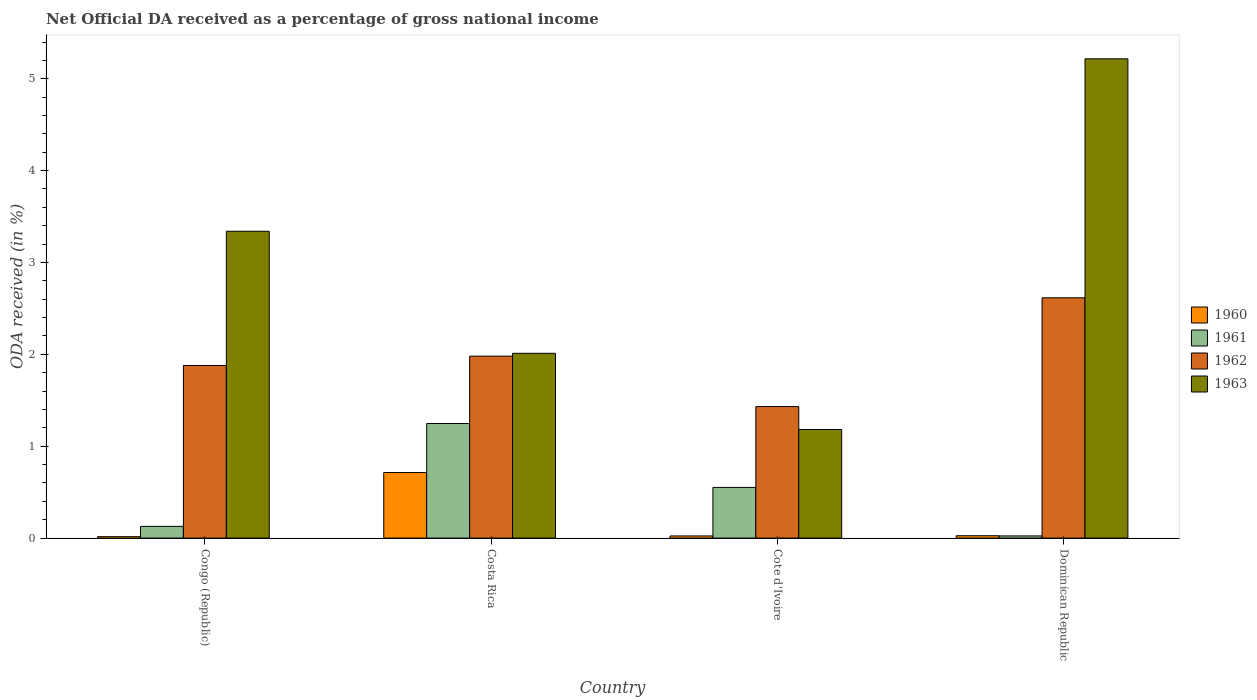Are the number of bars per tick equal to the number of legend labels?
Offer a very short reply. Yes. What is the label of the 3rd group of bars from the left?
Offer a very short reply. Cote d'Ivoire. In how many cases, is the number of bars for a given country not equal to the number of legend labels?
Your answer should be compact. 0. What is the net official DA received in 1960 in Cote d'Ivoire?
Make the answer very short. 0.02. Across all countries, what is the maximum net official DA received in 1960?
Ensure brevity in your answer.  0.71. Across all countries, what is the minimum net official DA received in 1962?
Provide a short and direct response. 1.43. In which country was the net official DA received in 1961 maximum?
Your answer should be very brief. Costa Rica. In which country was the net official DA received in 1960 minimum?
Ensure brevity in your answer.  Congo (Republic). What is the total net official DA received in 1962 in the graph?
Your response must be concise. 7.91. What is the difference between the net official DA received in 1960 in Congo (Republic) and that in Dominican Republic?
Your answer should be compact. -0.01. What is the difference between the net official DA received in 1961 in Dominican Republic and the net official DA received in 1963 in Congo (Republic)?
Provide a succinct answer. -3.32. What is the average net official DA received in 1963 per country?
Make the answer very short. 2.94. What is the difference between the net official DA received of/in 1963 and net official DA received of/in 1962 in Dominican Republic?
Provide a short and direct response. 2.6. What is the ratio of the net official DA received in 1961 in Congo (Republic) to that in Cote d'Ivoire?
Provide a short and direct response. 0.23. Is the net official DA received in 1960 in Costa Rica less than that in Cote d'Ivoire?
Offer a terse response. No. What is the difference between the highest and the second highest net official DA received in 1962?
Your response must be concise. -0.64. What is the difference between the highest and the lowest net official DA received in 1962?
Make the answer very short. 1.18. In how many countries, is the net official DA received in 1960 greater than the average net official DA received in 1960 taken over all countries?
Your answer should be very brief. 1. How many bars are there?
Provide a short and direct response. 16. Are all the bars in the graph horizontal?
Your response must be concise. No. Are the values on the major ticks of Y-axis written in scientific E-notation?
Keep it short and to the point. No. Does the graph contain any zero values?
Offer a terse response. No. Where does the legend appear in the graph?
Offer a very short reply. Center right. What is the title of the graph?
Give a very brief answer. Net Official DA received as a percentage of gross national income. Does "1962" appear as one of the legend labels in the graph?
Provide a short and direct response. Yes. What is the label or title of the X-axis?
Offer a very short reply. Country. What is the label or title of the Y-axis?
Your response must be concise. ODA received (in %). What is the ODA received (in %) in 1960 in Congo (Republic)?
Your answer should be compact. 0.02. What is the ODA received (in %) in 1961 in Congo (Republic)?
Ensure brevity in your answer.  0.13. What is the ODA received (in %) of 1962 in Congo (Republic)?
Keep it short and to the point. 1.88. What is the ODA received (in %) in 1963 in Congo (Republic)?
Offer a very short reply. 3.34. What is the ODA received (in %) of 1960 in Costa Rica?
Keep it short and to the point. 0.71. What is the ODA received (in %) of 1961 in Costa Rica?
Provide a succinct answer. 1.25. What is the ODA received (in %) of 1962 in Costa Rica?
Keep it short and to the point. 1.98. What is the ODA received (in %) of 1963 in Costa Rica?
Make the answer very short. 2.01. What is the ODA received (in %) in 1960 in Cote d'Ivoire?
Provide a short and direct response. 0.02. What is the ODA received (in %) of 1961 in Cote d'Ivoire?
Your answer should be compact. 0.55. What is the ODA received (in %) in 1962 in Cote d'Ivoire?
Ensure brevity in your answer.  1.43. What is the ODA received (in %) in 1963 in Cote d'Ivoire?
Your response must be concise. 1.18. What is the ODA received (in %) of 1960 in Dominican Republic?
Offer a very short reply. 0.03. What is the ODA received (in %) in 1961 in Dominican Republic?
Your answer should be very brief. 0.02. What is the ODA received (in %) in 1962 in Dominican Republic?
Offer a terse response. 2.62. What is the ODA received (in %) of 1963 in Dominican Republic?
Ensure brevity in your answer.  5.22. Across all countries, what is the maximum ODA received (in %) of 1960?
Your answer should be very brief. 0.71. Across all countries, what is the maximum ODA received (in %) of 1961?
Ensure brevity in your answer.  1.25. Across all countries, what is the maximum ODA received (in %) of 1962?
Your response must be concise. 2.62. Across all countries, what is the maximum ODA received (in %) in 1963?
Your answer should be compact. 5.22. Across all countries, what is the minimum ODA received (in %) of 1960?
Your answer should be compact. 0.02. Across all countries, what is the minimum ODA received (in %) in 1961?
Make the answer very short. 0.02. Across all countries, what is the minimum ODA received (in %) in 1962?
Ensure brevity in your answer.  1.43. Across all countries, what is the minimum ODA received (in %) of 1963?
Make the answer very short. 1.18. What is the total ODA received (in %) of 1960 in the graph?
Your answer should be compact. 0.78. What is the total ODA received (in %) in 1961 in the graph?
Give a very brief answer. 1.95. What is the total ODA received (in %) of 1962 in the graph?
Offer a terse response. 7.91. What is the total ODA received (in %) of 1963 in the graph?
Offer a very short reply. 11.75. What is the difference between the ODA received (in %) in 1960 in Congo (Republic) and that in Costa Rica?
Your answer should be compact. -0.7. What is the difference between the ODA received (in %) in 1961 in Congo (Republic) and that in Costa Rica?
Your answer should be compact. -1.12. What is the difference between the ODA received (in %) in 1962 in Congo (Republic) and that in Costa Rica?
Give a very brief answer. -0.1. What is the difference between the ODA received (in %) of 1963 in Congo (Republic) and that in Costa Rica?
Make the answer very short. 1.33. What is the difference between the ODA received (in %) of 1960 in Congo (Republic) and that in Cote d'Ivoire?
Provide a succinct answer. -0.01. What is the difference between the ODA received (in %) in 1961 in Congo (Republic) and that in Cote d'Ivoire?
Provide a short and direct response. -0.42. What is the difference between the ODA received (in %) in 1962 in Congo (Republic) and that in Cote d'Ivoire?
Provide a succinct answer. 0.45. What is the difference between the ODA received (in %) of 1963 in Congo (Republic) and that in Cote d'Ivoire?
Offer a terse response. 2.16. What is the difference between the ODA received (in %) of 1960 in Congo (Republic) and that in Dominican Republic?
Give a very brief answer. -0.01. What is the difference between the ODA received (in %) of 1961 in Congo (Republic) and that in Dominican Republic?
Your response must be concise. 0.1. What is the difference between the ODA received (in %) in 1962 in Congo (Republic) and that in Dominican Republic?
Offer a terse response. -0.74. What is the difference between the ODA received (in %) of 1963 in Congo (Republic) and that in Dominican Republic?
Provide a short and direct response. -1.88. What is the difference between the ODA received (in %) of 1960 in Costa Rica and that in Cote d'Ivoire?
Keep it short and to the point. 0.69. What is the difference between the ODA received (in %) in 1961 in Costa Rica and that in Cote d'Ivoire?
Keep it short and to the point. 0.7. What is the difference between the ODA received (in %) in 1962 in Costa Rica and that in Cote d'Ivoire?
Keep it short and to the point. 0.55. What is the difference between the ODA received (in %) in 1963 in Costa Rica and that in Cote d'Ivoire?
Make the answer very short. 0.83. What is the difference between the ODA received (in %) of 1960 in Costa Rica and that in Dominican Republic?
Offer a terse response. 0.69. What is the difference between the ODA received (in %) of 1961 in Costa Rica and that in Dominican Republic?
Your answer should be very brief. 1.22. What is the difference between the ODA received (in %) in 1962 in Costa Rica and that in Dominican Republic?
Your answer should be very brief. -0.64. What is the difference between the ODA received (in %) in 1963 in Costa Rica and that in Dominican Republic?
Make the answer very short. -3.21. What is the difference between the ODA received (in %) of 1960 in Cote d'Ivoire and that in Dominican Republic?
Ensure brevity in your answer.  -0. What is the difference between the ODA received (in %) in 1961 in Cote d'Ivoire and that in Dominican Republic?
Make the answer very short. 0.53. What is the difference between the ODA received (in %) in 1962 in Cote d'Ivoire and that in Dominican Republic?
Offer a very short reply. -1.18. What is the difference between the ODA received (in %) of 1963 in Cote d'Ivoire and that in Dominican Republic?
Make the answer very short. -4.03. What is the difference between the ODA received (in %) of 1960 in Congo (Republic) and the ODA received (in %) of 1961 in Costa Rica?
Make the answer very short. -1.23. What is the difference between the ODA received (in %) in 1960 in Congo (Republic) and the ODA received (in %) in 1962 in Costa Rica?
Your answer should be compact. -1.96. What is the difference between the ODA received (in %) of 1960 in Congo (Republic) and the ODA received (in %) of 1963 in Costa Rica?
Offer a very short reply. -2. What is the difference between the ODA received (in %) in 1961 in Congo (Republic) and the ODA received (in %) in 1962 in Costa Rica?
Keep it short and to the point. -1.85. What is the difference between the ODA received (in %) of 1961 in Congo (Republic) and the ODA received (in %) of 1963 in Costa Rica?
Your answer should be very brief. -1.88. What is the difference between the ODA received (in %) in 1962 in Congo (Republic) and the ODA received (in %) in 1963 in Costa Rica?
Keep it short and to the point. -0.13. What is the difference between the ODA received (in %) of 1960 in Congo (Republic) and the ODA received (in %) of 1961 in Cote d'Ivoire?
Your answer should be compact. -0.54. What is the difference between the ODA received (in %) in 1960 in Congo (Republic) and the ODA received (in %) in 1962 in Cote d'Ivoire?
Provide a succinct answer. -1.42. What is the difference between the ODA received (in %) in 1960 in Congo (Republic) and the ODA received (in %) in 1963 in Cote d'Ivoire?
Make the answer very short. -1.17. What is the difference between the ODA received (in %) in 1961 in Congo (Republic) and the ODA received (in %) in 1962 in Cote d'Ivoire?
Give a very brief answer. -1.3. What is the difference between the ODA received (in %) of 1961 in Congo (Republic) and the ODA received (in %) of 1963 in Cote d'Ivoire?
Give a very brief answer. -1.05. What is the difference between the ODA received (in %) in 1962 in Congo (Republic) and the ODA received (in %) in 1963 in Cote d'Ivoire?
Your answer should be very brief. 0.7. What is the difference between the ODA received (in %) in 1960 in Congo (Republic) and the ODA received (in %) in 1961 in Dominican Republic?
Your response must be concise. -0.01. What is the difference between the ODA received (in %) of 1960 in Congo (Republic) and the ODA received (in %) of 1962 in Dominican Republic?
Your answer should be very brief. -2.6. What is the difference between the ODA received (in %) in 1960 in Congo (Republic) and the ODA received (in %) in 1963 in Dominican Republic?
Keep it short and to the point. -5.2. What is the difference between the ODA received (in %) in 1961 in Congo (Republic) and the ODA received (in %) in 1962 in Dominican Republic?
Offer a very short reply. -2.49. What is the difference between the ODA received (in %) in 1961 in Congo (Republic) and the ODA received (in %) in 1963 in Dominican Republic?
Your response must be concise. -5.09. What is the difference between the ODA received (in %) of 1962 in Congo (Republic) and the ODA received (in %) of 1963 in Dominican Republic?
Keep it short and to the point. -3.34. What is the difference between the ODA received (in %) of 1960 in Costa Rica and the ODA received (in %) of 1961 in Cote d'Ivoire?
Your response must be concise. 0.16. What is the difference between the ODA received (in %) of 1960 in Costa Rica and the ODA received (in %) of 1962 in Cote d'Ivoire?
Keep it short and to the point. -0.72. What is the difference between the ODA received (in %) of 1960 in Costa Rica and the ODA received (in %) of 1963 in Cote d'Ivoire?
Offer a very short reply. -0.47. What is the difference between the ODA received (in %) of 1961 in Costa Rica and the ODA received (in %) of 1962 in Cote d'Ivoire?
Offer a very short reply. -0.18. What is the difference between the ODA received (in %) in 1961 in Costa Rica and the ODA received (in %) in 1963 in Cote d'Ivoire?
Give a very brief answer. 0.07. What is the difference between the ODA received (in %) in 1962 in Costa Rica and the ODA received (in %) in 1963 in Cote d'Ivoire?
Offer a very short reply. 0.8. What is the difference between the ODA received (in %) in 1960 in Costa Rica and the ODA received (in %) in 1961 in Dominican Republic?
Your answer should be compact. 0.69. What is the difference between the ODA received (in %) in 1960 in Costa Rica and the ODA received (in %) in 1962 in Dominican Republic?
Keep it short and to the point. -1.9. What is the difference between the ODA received (in %) of 1960 in Costa Rica and the ODA received (in %) of 1963 in Dominican Republic?
Keep it short and to the point. -4.5. What is the difference between the ODA received (in %) of 1961 in Costa Rica and the ODA received (in %) of 1962 in Dominican Republic?
Your response must be concise. -1.37. What is the difference between the ODA received (in %) of 1961 in Costa Rica and the ODA received (in %) of 1963 in Dominican Republic?
Ensure brevity in your answer.  -3.97. What is the difference between the ODA received (in %) of 1962 in Costa Rica and the ODA received (in %) of 1963 in Dominican Republic?
Make the answer very short. -3.24. What is the difference between the ODA received (in %) of 1960 in Cote d'Ivoire and the ODA received (in %) of 1961 in Dominican Republic?
Provide a short and direct response. -0. What is the difference between the ODA received (in %) in 1960 in Cote d'Ivoire and the ODA received (in %) in 1962 in Dominican Republic?
Give a very brief answer. -2.59. What is the difference between the ODA received (in %) of 1960 in Cote d'Ivoire and the ODA received (in %) of 1963 in Dominican Republic?
Offer a terse response. -5.19. What is the difference between the ODA received (in %) of 1961 in Cote d'Ivoire and the ODA received (in %) of 1962 in Dominican Republic?
Offer a terse response. -2.06. What is the difference between the ODA received (in %) of 1961 in Cote d'Ivoire and the ODA received (in %) of 1963 in Dominican Republic?
Provide a short and direct response. -4.67. What is the difference between the ODA received (in %) of 1962 in Cote d'Ivoire and the ODA received (in %) of 1963 in Dominican Republic?
Your response must be concise. -3.79. What is the average ODA received (in %) in 1960 per country?
Provide a short and direct response. 0.19. What is the average ODA received (in %) of 1961 per country?
Make the answer very short. 0.49. What is the average ODA received (in %) of 1962 per country?
Provide a succinct answer. 1.98. What is the average ODA received (in %) of 1963 per country?
Ensure brevity in your answer.  2.94. What is the difference between the ODA received (in %) of 1960 and ODA received (in %) of 1961 in Congo (Republic)?
Give a very brief answer. -0.11. What is the difference between the ODA received (in %) of 1960 and ODA received (in %) of 1962 in Congo (Republic)?
Keep it short and to the point. -1.86. What is the difference between the ODA received (in %) in 1960 and ODA received (in %) in 1963 in Congo (Republic)?
Give a very brief answer. -3.32. What is the difference between the ODA received (in %) of 1961 and ODA received (in %) of 1962 in Congo (Republic)?
Your response must be concise. -1.75. What is the difference between the ODA received (in %) in 1961 and ODA received (in %) in 1963 in Congo (Republic)?
Make the answer very short. -3.21. What is the difference between the ODA received (in %) in 1962 and ODA received (in %) in 1963 in Congo (Republic)?
Offer a very short reply. -1.46. What is the difference between the ODA received (in %) of 1960 and ODA received (in %) of 1961 in Costa Rica?
Your answer should be very brief. -0.53. What is the difference between the ODA received (in %) in 1960 and ODA received (in %) in 1962 in Costa Rica?
Keep it short and to the point. -1.27. What is the difference between the ODA received (in %) in 1960 and ODA received (in %) in 1963 in Costa Rica?
Make the answer very short. -1.3. What is the difference between the ODA received (in %) of 1961 and ODA received (in %) of 1962 in Costa Rica?
Provide a short and direct response. -0.73. What is the difference between the ODA received (in %) in 1961 and ODA received (in %) in 1963 in Costa Rica?
Keep it short and to the point. -0.76. What is the difference between the ODA received (in %) of 1962 and ODA received (in %) of 1963 in Costa Rica?
Make the answer very short. -0.03. What is the difference between the ODA received (in %) of 1960 and ODA received (in %) of 1961 in Cote d'Ivoire?
Offer a very short reply. -0.53. What is the difference between the ODA received (in %) in 1960 and ODA received (in %) in 1962 in Cote d'Ivoire?
Your answer should be very brief. -1.41. What is the difference between the ODA received (in %) in 1960 and ODA received (in %) in 1963 in Cote d'Ivoire?
Keep it short and to the point. -1.16. What is the difference between the ODA received (in %) of 1961 and ODA received (in %) of 1962 in Cote d'Ivoire?
Make the answer very short. -0.88. What is the difference between the ODA received (in %) of 1961 and ODA received (in %) of 1963 in Cote d'Ivoire?
Your answer should be compact. -0.63. What is the difference between the ODA received (in %) of 1962 and ODA received (in %) of 1963 in Cote d'Ivoire?
Make the answer very short. 0.25. What is the difference between the ODA received (in %) in 1960 and ODA received (in %) in 1961 in Dominican Republic?
Provide a succinct answer. 0. What is the difference between the ODA received (in %) in 1960 and ODA received (in %) in 1962 in Dominican Republic?
Your response must be concise. -2.59. What is the difference between the ODA received (in %) in 1960 and ODA received (in %) in 1963 in Dominican Republic?
Offer a very short reply. -5.19. What is the difference between the ODA received (in %) in 1961 and ODA received (in %) in 1962 in Dominican Republic?
Offer a terse response. -2.59. What is the difference between the ODA received (in %) of 1961 and ODA received (in %) of 1963 in Dominican Republic?
Give a very brief answer. -5.19. What is the difference between the ODA received (in %) of 1962 and ODA received (in %) of 1963 in Dominican Republic?
Keep it short and to the point. -2.6. What is the ratio of the ODA received (in %) of 1960 in Congo (Republic) to that in Costa Rica?
Your response must be concise. 0.02. What is the ratio of the ODA received (in %) in 1961 in Congo (Republic) to that in Costa Rica?
Offer a terse response. 0.1. What is the ratio of the ODA received (in %) of 1962 in Congo (Republic) to that in Costa Rica?
Give a very brief answer. 0.95. What is the ratio of the ODA received (in %) of 1963 in Congo (Republic) to that in Costa Rica?
Your answer should be compact. 1.66. What is the ratio of the ODA received (in %) in 1960 in Congo (Republic) to that in Cote d'Ivoire?
Your response must be concise. 0.66. What is the ratio of the ODA received (in %) of 1961 in Congo (Republic) to that in Cote d'Ivoire?
Provide a short and direct response. 0.23. What is the ratio of the ODA received (in %) in 1962 in Congo (Republic) to that in Cote d'Ivoire?
Provide a succinct answer. 1.31. What is the ratio of the ODA received (in %) in 1963 in Congo (Republic) to that in Cote d'Ivoire?
Provide a short and direct response. 2.83. What is the ratio of the ODA received (in %) in 1960 in Congo (Republic) to that in Dominican Republic?
Provide a succinct answer. 0.6. What is the ratio of the ODA received (in %) in 1961 in Congo (Republic) to that in Dominican Republic?
Provide a short and direct response. 5.41. What is the ratio of the ODA received (in %) in 1962 in Congo (Republic) to that in Dominican Republic?
Your response must be concise. 0.72. What is the ratio of the ODA received (in %) in 1963 in Congo (Republic) to that in Dominican Republic?
Your answer should be very brief. 0.64. What is the ratio of the ODA received (in %) in 1960 in Costa Rica to that in Cote d'Ivoire?
Give a very brief answer. 30.57. What is the ratio of the ODA received (in %) of 1961 in Costa Rica to that in Cote d'Ivoire?
Your answer should be compact. 2.26. What is the ratio of the ODA received (in %) of 1962 in Costa Rica to that in Cote d'Ivoire?
Make the answer very short. 1.38. What is the ratio of the ODA received (in %) of 1963 in Costa Rica to that in Cote d'Ivoire?
Your answer should be compact. 1.7. What is the ratio of the ODA received (in %) in 1960 in Costa Rica to that in Dominican Republic?
Provide a short and direct response. 27.82. What is the ratio of the ODA received (in %) of 1961 in Costa Rica to that in Dominican Republic?
Your answer should be very brief. 52.85. What is the ratio of the ODA received (in %) in 1962 in Costa Rica to that in Dominican Republic?
Offer a terse response. 0.76. What is the ratio of the ODA received (in %) of 1963 in Costa Rica to that in Dominican Republic?
Offer a very short reply. 0.39. What is the ratio of the ODA received (in %) in 1960 in Cote d'Ivoire to that in Dominican Republic?
Make the answer very short. 0.91. What is the ratio of the ODA received (in %) of 1961 in Cote d'Ivoire to that in Dominican Republic?
Ensure brevity in your answer.  23.38. What is the ratio of the ODA received (in %) of 1962 in Cote d'Ivoire to that in Dominican Republic?
Offer a very short reply. 0.55. What is the ratio of the ODA received (in %) in 1963 in Cote d'Ivoire to that in Dominican Republic?
Give a very brief answer. 0.23. What is the difference between the highest and the second highest ODA received (in %) of 1960?
Your answer should be compact. 0.69. What is the difference between the highest and the second highest ODA received (in %) of 1961?
Your answer should be compact. 0.7. What is the difference between the highest and the second highest ODA received (in %) of 1962?
Give a very brief answer. 0.64. What is the difference between the highest and the second highest ODA received (in %) of 1963?
Ensure brevity in your answer.  1.88. What is the difference between the highest and the lowest ODA received (in %) of 1960?
Ensure brevity in your answer.  0.7. What is the difference between the highest and the lowest ODA received (in %) of 1961?
Keep it short and to the point. 1.22. What is the difference between the highest and the lowest ODA received (in %) of 1962?
Your answer should be compact. 1.18. What is the difference between the highest and the lowest ODA received (in %) of 1963?
Ensure brevity in your answer.  4.03. 